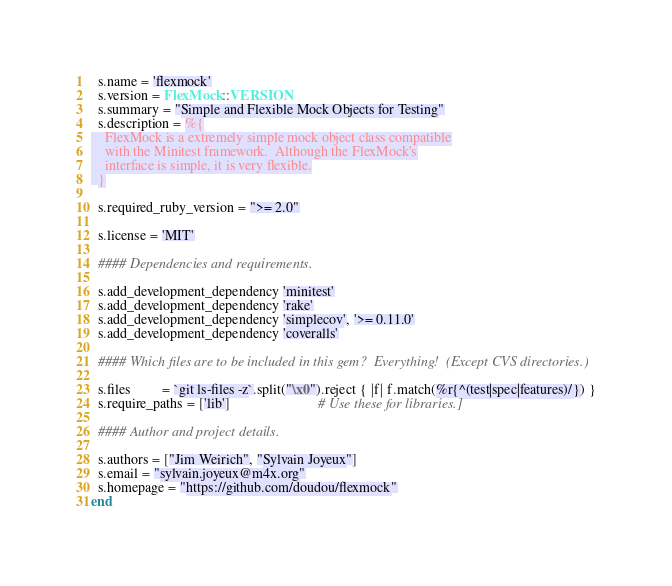Convert code to text. <code><loc_0><loc_0><loc_500><loc_500><_Ruby_>  s.name = 'flexmock'
  s.version = FlexMock::VERSION
  s.summary = "Simple and Flexible Mock Objects for Testing"
  s.description = %{
    FlexMock is a extremely simple mock object class compatible
    with the Minitest framework.  Although the FlexMock's
    interface is simple, it is very flexible.
  }

  s.required_ruby_version = ">= 2.0"

  s.license = 'MIT'

  #### Dependencies and requirements.

  s.add_development_dependency 'minitest'
  s.add_development_dependency 'rake'
  s.add_development_dependency 'simplecov', '>= 0.11.0'
  s.add_development_dependency 'coveralls'

  #### Which files are to be included in this gem?  Everything!  (Except CVS directories.)

  s.files         = `git ls-files -z`.split("\x0").reject { |f| f.match(%r{^(test|spec|features)/}) }
  s.require_paths = ['lib']                         # Use these for libraries.]

  #### Author and project details.

  s.authors = ["Jim Weirich", "Sylvain Joyeux"]
  s.email = "sylvain.joyeux@m4x.org"
  s.homepage = "https://github.com/doudou/flexmock"
end

</code> 